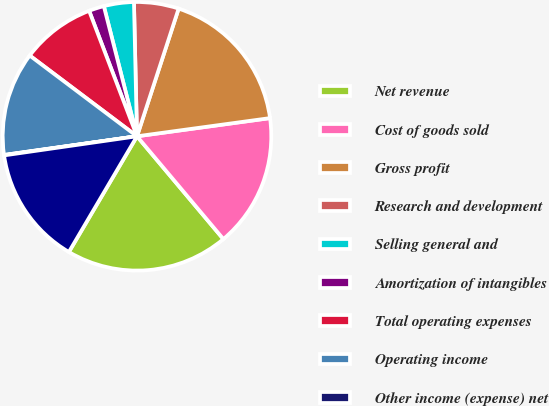Convert chart to OTSL. <chart><loc_0><loc_0><loc_500><loc_500><pie_chart><fcel>Net revenue<fcel>Cost of goods sold<fcel>Gross profit<fcel>Research and development<fcel>Selling general and<fcel>Amortization of intangibles<fcel>Total operating expenses<fcel>Operating income<fcel>Other income (expense) net<fcel>Income before income taxes<nl><fcel>19.59%<fcel>16.04%<fcel>17.82%<fcel>5.38%<fcel>3.61%<fcel>1.83%<fcel>8.93%<fcel>12.49%<fcel>0.05%<fcel>14.26%<nl></chart> 